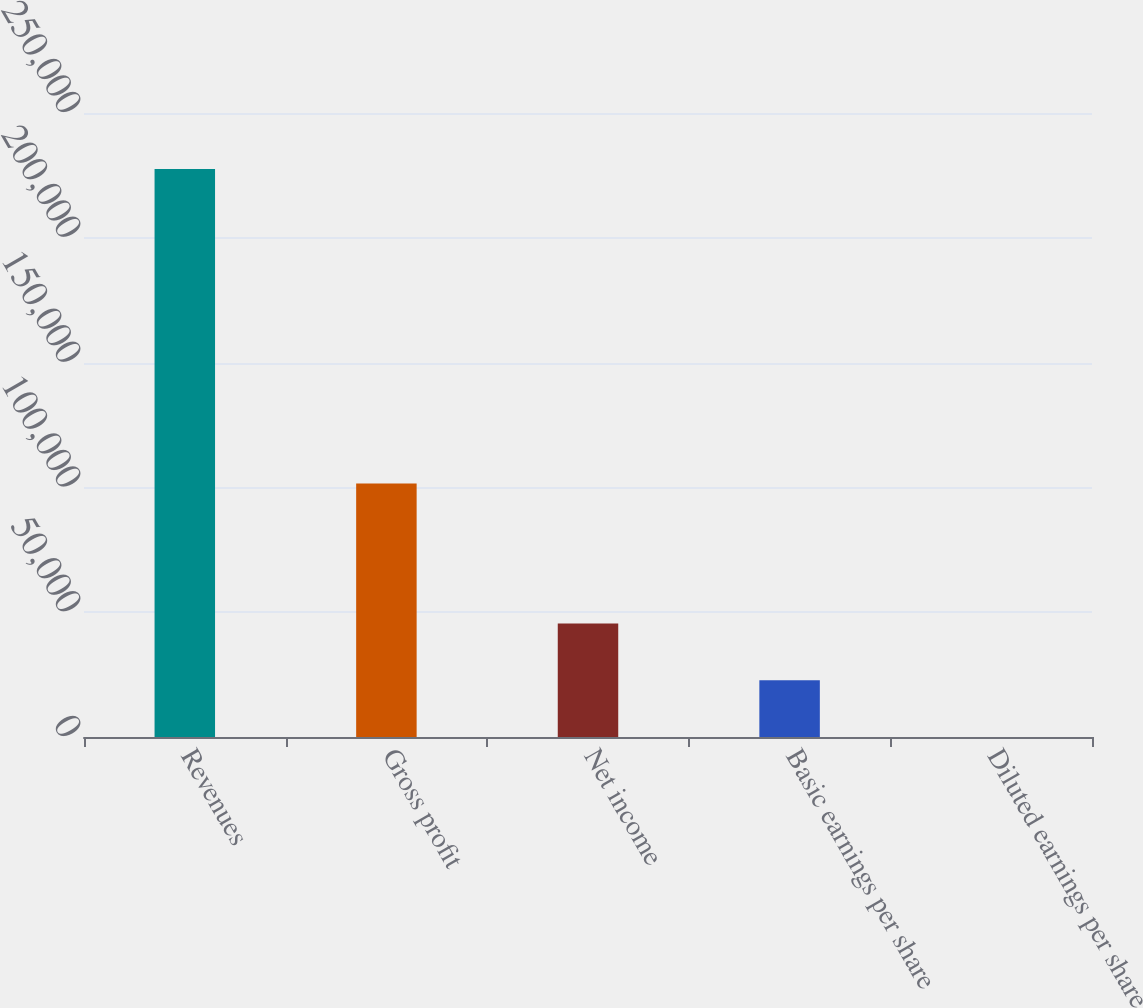Convert chart to OTSL. <chart><loc_0><loc_0><loc_500><loc_500><bar_chart><fcel>Revenues<fcel>Gross profit<fcel>Net income<fcel>Basic earnings per share<fcel>Diluted earnings per share<nl><fcel>227558<fcel>101551<fcel>45512<fcel>22756.2<fcel>0.47<nl></chart> 